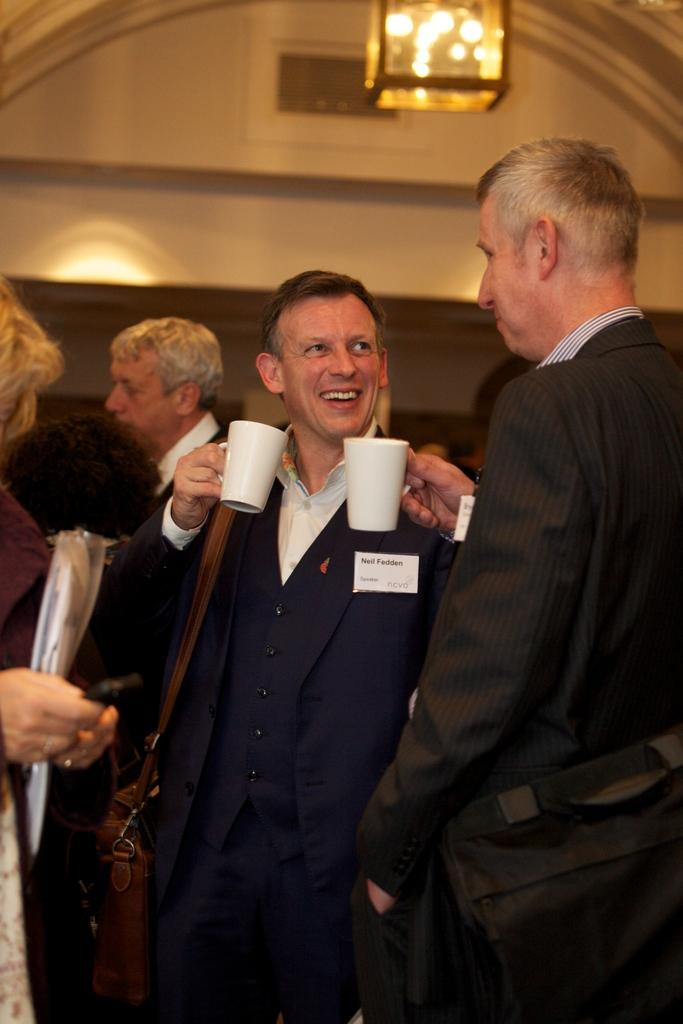How many people are in the image? There are people in the image. What are the first two people doing? The first two people are talking with each other. What are the people consuming in the image? The people are drinking coffee. What can be seen in the background of the image? There is a light and a wall in the background of the image. How many minutes does it take for the girl to finish her coffee in the image? There is no girl present in the image, and therefore no information about her coffee consumption. 